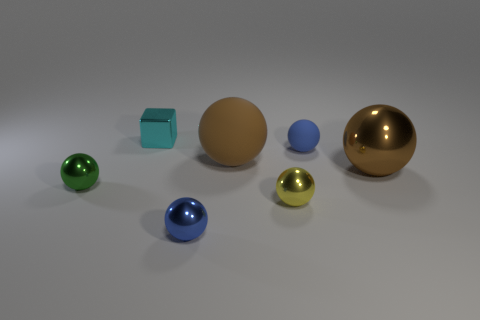How many other things are the same color as the large matte thing?
Your response must be concise. 1. There is a tiny blue thing behind the large sphere that is behind the big brown ball that is on the right side of the small yellow sphere; what is its material?
Provide a succinct answer. Rubber. What number of balls are either small green objects or large things?
Provide a short and direct response. 3. There is a big brown ball that is right of the small blue ball that is behind the small blue metal object; what number of big objects are left of it?
Make the answer very short. 1. Is the shape of the green shiny object the same as the large rubber thing?
Keep it short and to the point. Yes. Is the brown object on the left side of the large metallic object made of the same material as the small blue thing in front of the green object?
Your response must be concise. No. How many objects are either tiny things that are to the right of the tiny cyan shiny thing or metallic objects behind the small green shiny object?
Provide a succinct answer. 5. Is there anything else that has the same shape as the tiny cyan thing?
Keep it short and to the point. No. What number of small green balls are there?
Provide a short and direct response. 1. Is there a shiny block of the same size as the cyan shiny object?
Offer a very short reply. No. 